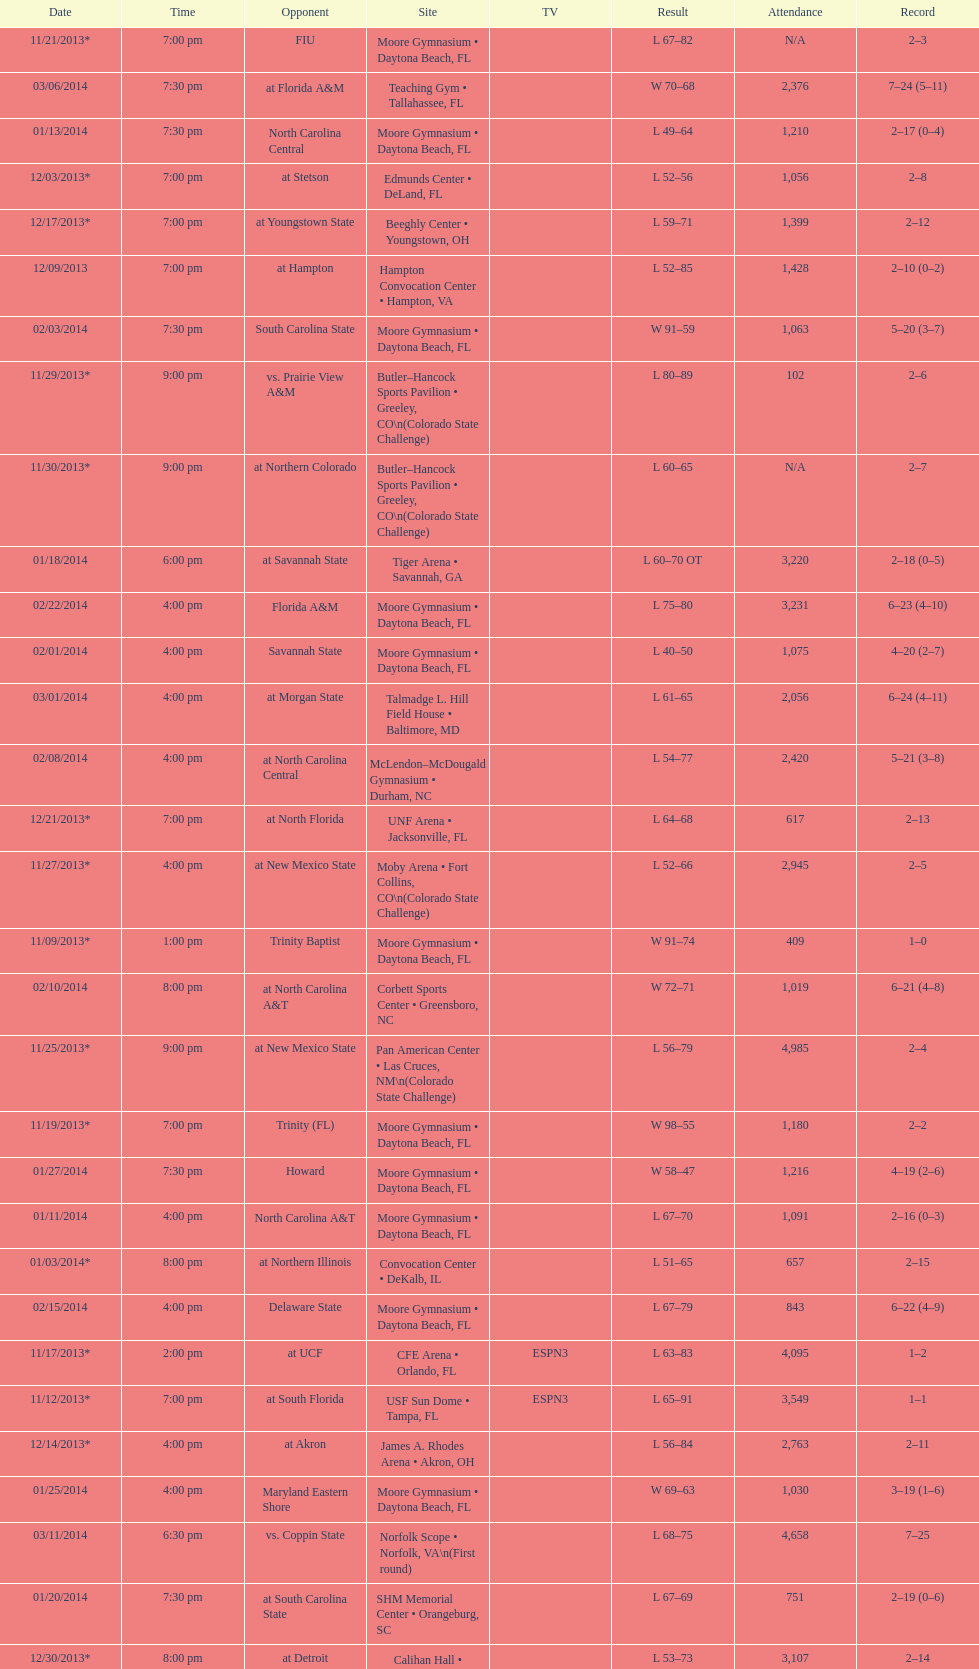How many games did the wildcats play in daytona beach, fl? 11. 